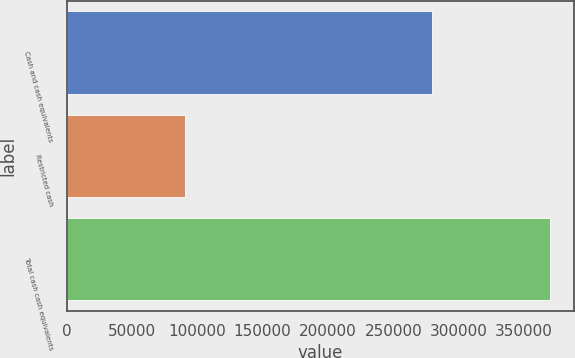<chart> <loc_0><loc_0><loc_500><loc_500><bar_chart><fcel>Cash and cash equivalents<fcel>Restricted cash<fcel>Total cash cash equivalents<nl><fcel>279443<fcel>90524<fcel>369967<nl></chart> 